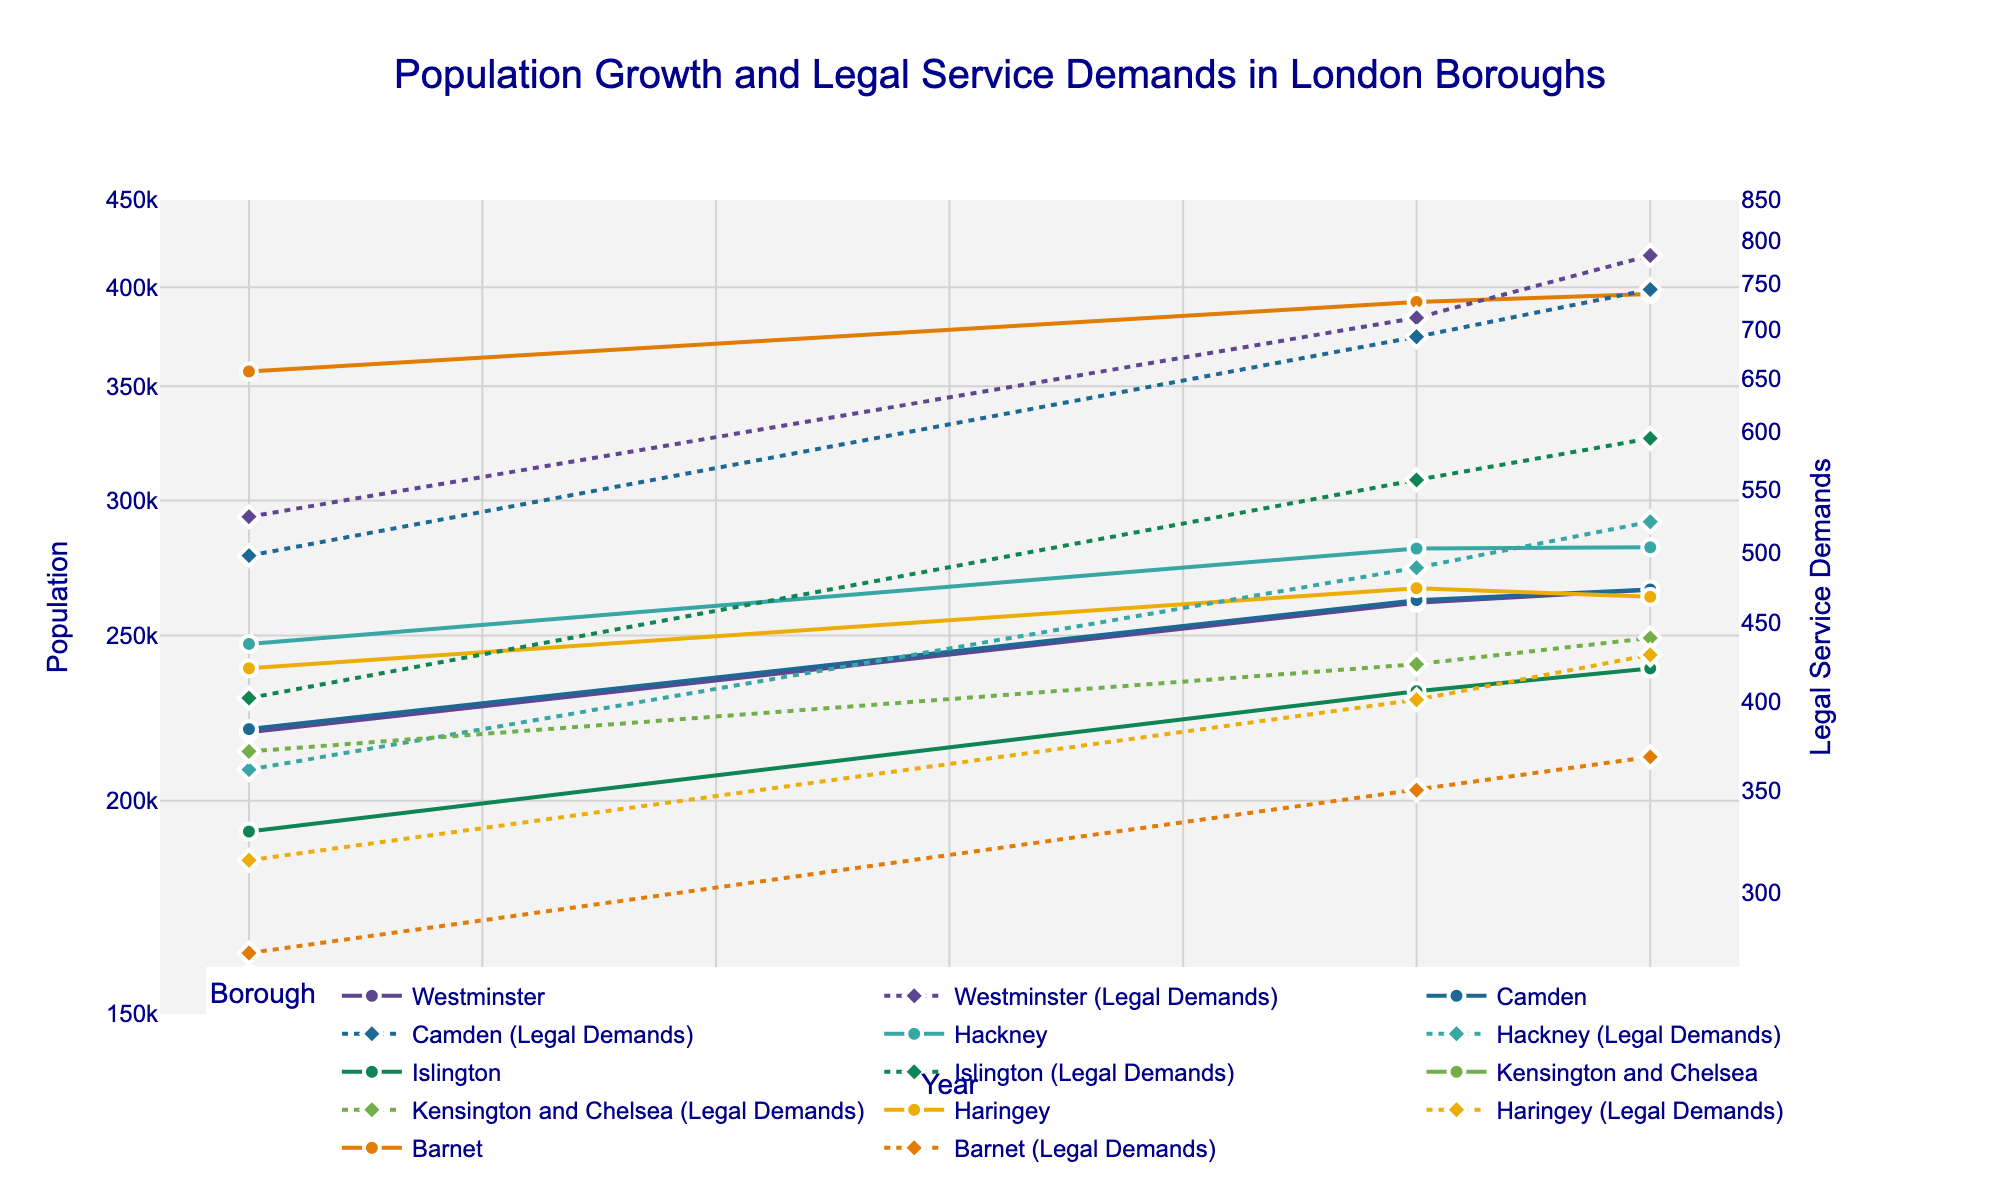What is the title of the figure? The title of the figure is displayed at the top of the chart. It is "Population Growth and Legal Service Demands in London Boroughs".
Answer: Population Growth and Legal Service Demands in London Boroughs What are the y-axis titles for both the primary and secondary y-axes? The y-axis titles are shown on both sides of the figure. The primary y-axis on the left-hand side is labeled "Population," and the secondary y-axis on the right-hand side is labeled "Legal Service Demands."
Answer: Population, Legal Service Demands How many boroughs are displayed in the figure? Each borough has a line with markers, and there are unique colors for each. By counting the legend entries or distinct colors in the figure, we can identify that there are seven boroughs displayed.
Answer: Seven Which borough had the highest population in 2022? To find the borough with the highest population in 2022, locate the endpoint for each population line on the figure and compare their values. Barnet's population is the highest in 2022.
Answer: Barnet What trend is observed in the population growth for Westminster between 2010 and 2022? Look for the line representing Westminster's population from 2010 to 2022. From the figure, Westminster’s population consistently increased over the years from 219,396 in 2010 to 265,910 in 2022.
Answer: Increasing What is the difference in Legal Service Demands between 2020 and 2022 for Camden? Locate Camden's legal service demands for 2020 and 2022. It shows 692 demands in 2020 and 743 in 2022. The difference is calculated by subtracting 692 from 743.
Answer: 51 How do the trends in Legal Service Demands compare between Hackney and Islington from 2010 to 2022? Observe the legal service demand lines for Hackney and Islington. Both lines show a rising trend from 2010 to 2022, but Islington has a steeper increase compared to Hackney.
Answer: Both increasing, Islington steeper Which borough showed a decline in population between 2010 and 2022? Look for any borough where the population line decreases from 2010 to 2022. Kensington and Chelsea shows a decline as it reduces from 158,329 in 2010 to 155,741 in 2022.
Answer: Kensington and Chelsea What can be inferred about the correlation between Population and Legal Service Demands within the boroughs? By observing that both metrics for most boroughs seem to increase over time, we can infer that there might be a positive correlation between population growth and legal service demands.
Answer: Positive correlation 